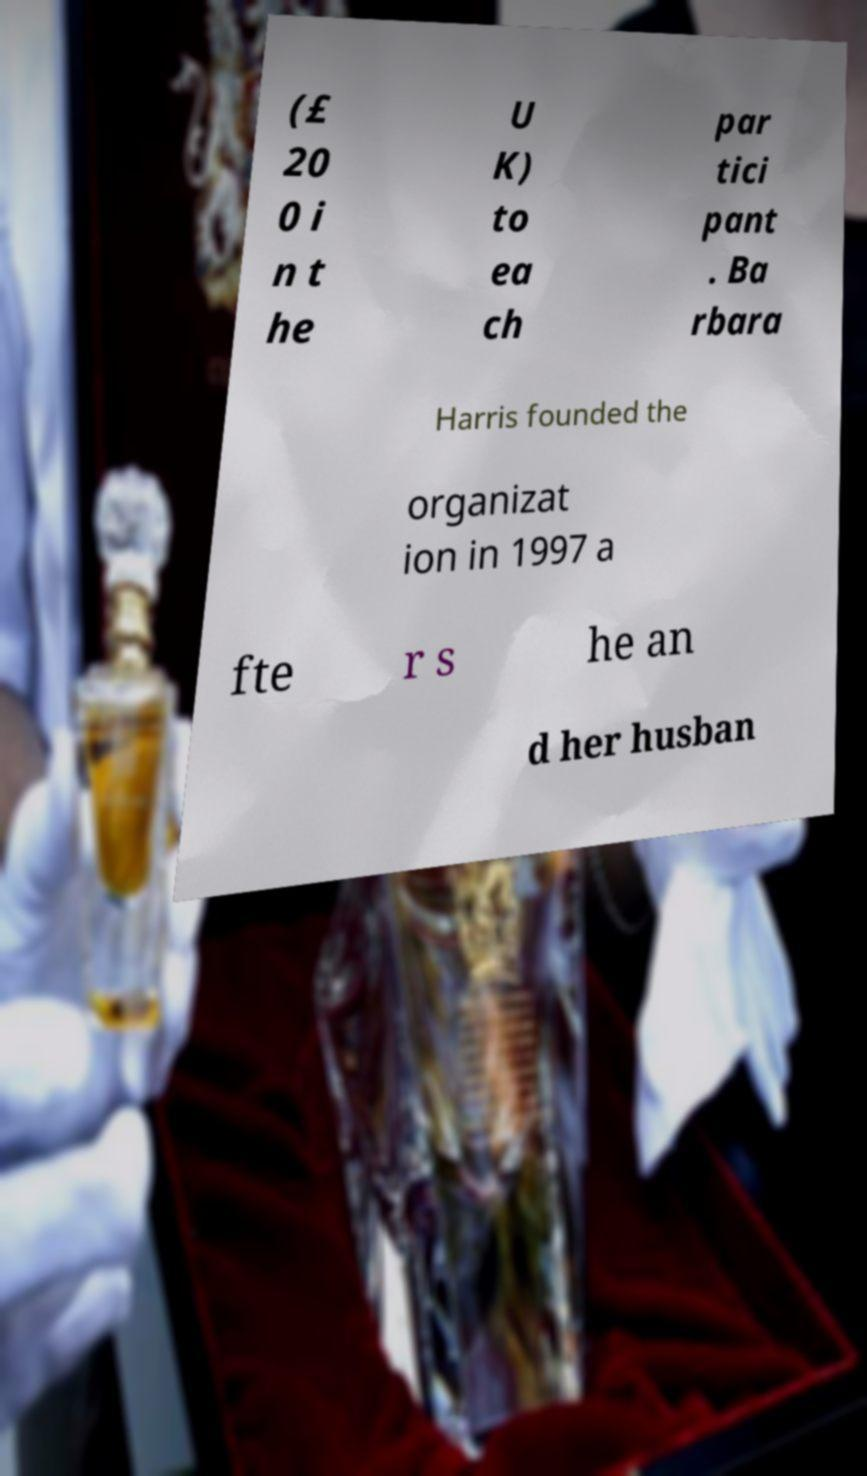For documentation purposes, I need the text within this image transcribed. Could you provide that? (£ 20 0 i n t he U K) to ea ch par tici pant . Ba rbara Harris founded the organizat ion in 1997 a fte r s he an d her husban 